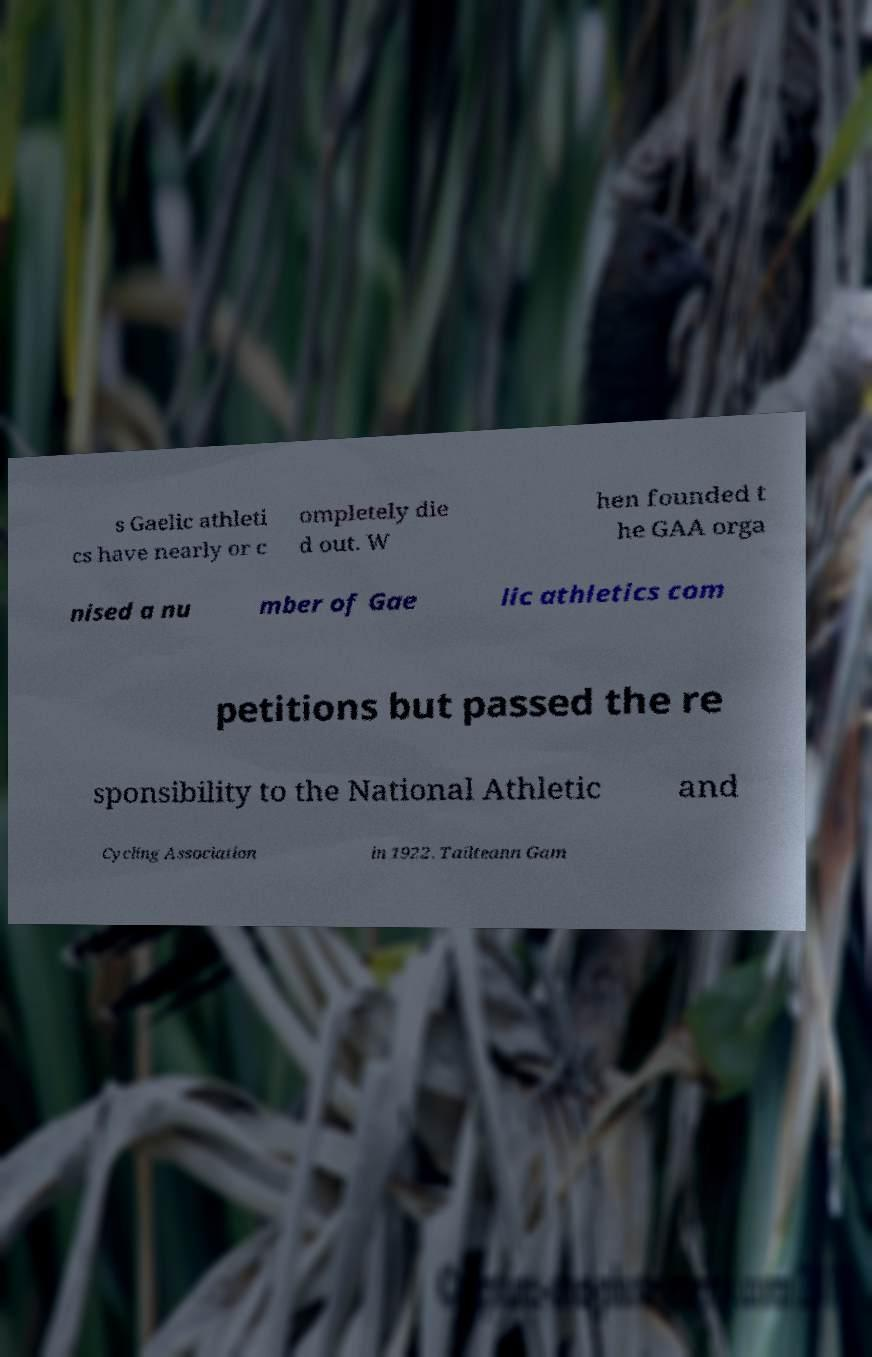I need the written content from this picture converted into text. Can you do that? s Gaelic athleti cs have nearly or c ompletely die d out. W hen founded t he GAA orga nised a nu mber of Gae lic athletics com petitions but passed the re sponsibility to the National Athletic and Cycling Association in 1922. Tailteann Gam 